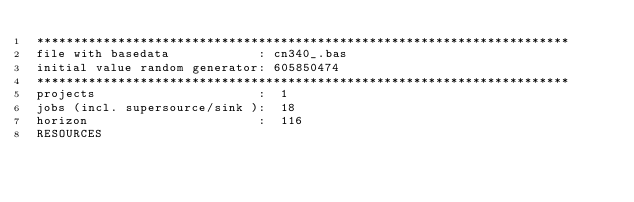<code> <loc_0><loc_0><loc_500><loc_500><_ObjectiveC_>************************************************************************
file with basedata            : cn340_.bas
initial value random generator: 605850474
************************************************************************
projects                      :  1
jobs (incl. supersource/sink ):  18
horizon                       :  116
RESOURCES</code> 